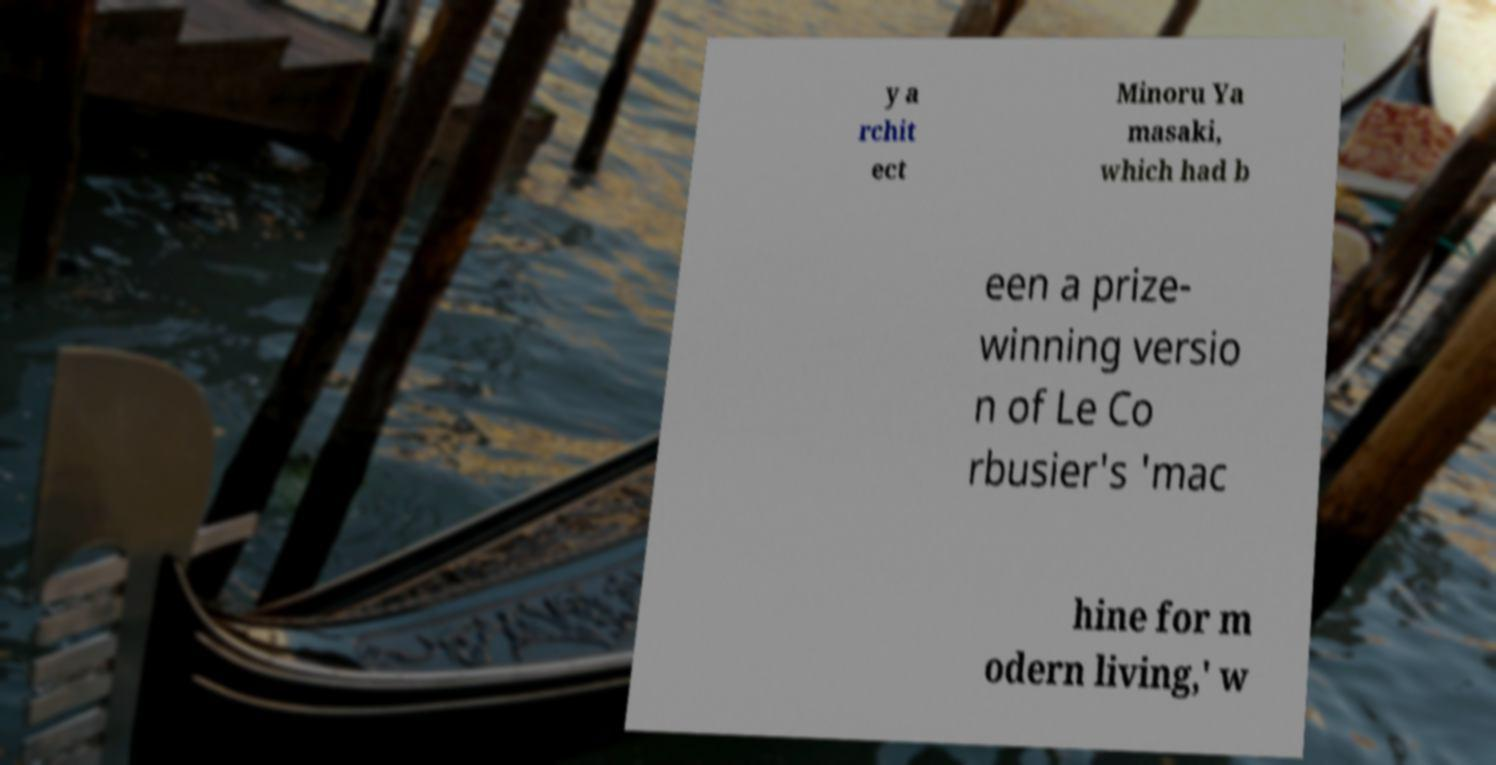Please identify and transcribe the text found in this image. y a rchit ect Minoru Ya masaki, which had b een a prize- winning versio n of Le Co rbusier's 'mac hine for m odern living,' w 